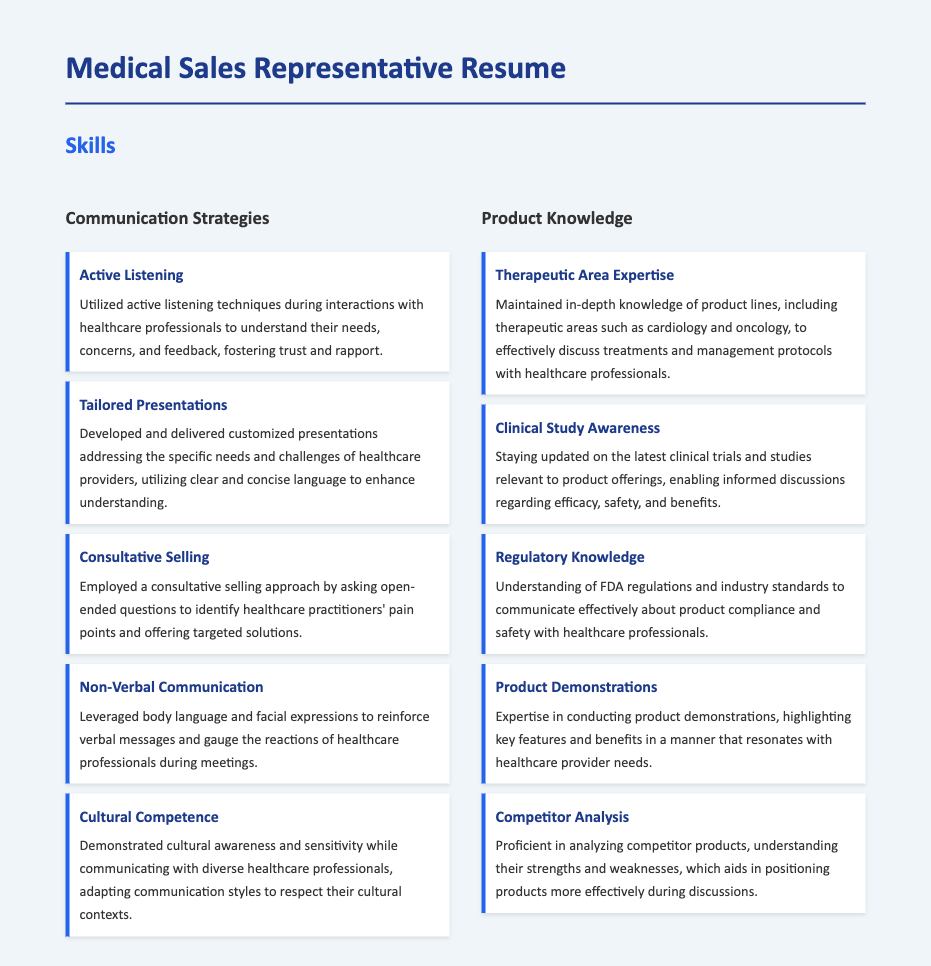What are the communication strategies listed? The document enumerates specific communication strategies under the Skills section.
Answer: Active Listening, Tailored Presentations, Consultative Selling, Non-Verbal Communication, Cultural Competence How many product knowledge areas are mentioned? The document outlines specific product knowledge areas listed under the Skills section, providing a clear count.
Answer: Five Which skill involves understanding cultural contexts? The document describes a skill that pertains to sensitivity and adaptation in communication styles with diverse individuals.
Answer: Cultural Competence What is the main focus of Therapeutic Area Expertise? This skill highlights a specific type of knowledge regarding the understanding of certain medical fields relevant to products.
Answer: Product lines Which strategy is related to gauging reactions? The document mentions a non-verbal approach that helps to perceive reactions from healthcare professionals during meetings.
Answer: Non-Verbal Communication What does Regulatory Knowledge help to communicate? The document indicates that this knowledge involves compliance and safety related to products, particularly in discussions with healthcare providers.
Answer: Product compliance How should presentations be tailored? The document suggests that presentations should be customized to address particular needs and challenges faced by healthcare providers.
Answer: Customized presentations What approach is used to identify pain points? This strategy involves asking specific types of questions to gather information regarding healthcare practitioners' challenges.
Answer: Consultative Selling 